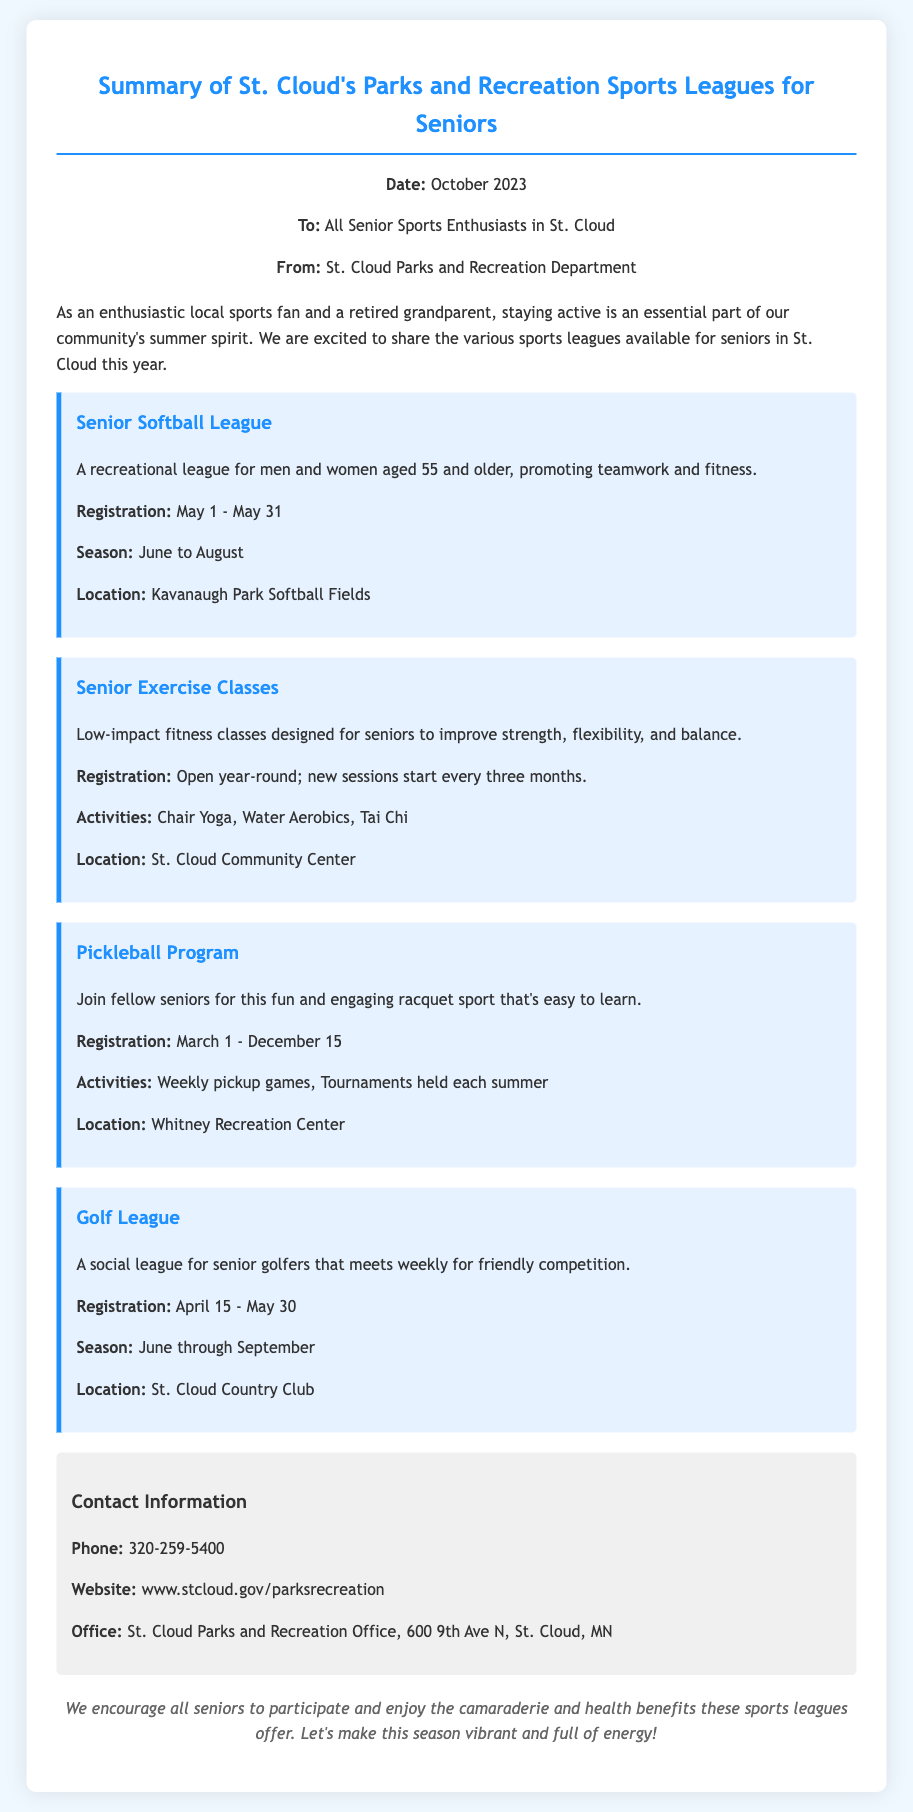What is the main theme of the memo? The main theme of the memo focuses on the various sports leagues available for seniors in St. Cloud to promote an active lifestyle.
Answer: Sports leagues for seniors When does registration for the Senior Softball League open? Registration for the Senior Softball League is specifically mentioned in the document to open on May 1.
Answer: May 1 How long is the registration period for the Golf League? The document specifies that the registration period for the Golf League extends from April 15 to May 30, which is 46 days.
Answer: 46 days What activities are included in the Senior Exercise Classes? The memo lists specific activities such as Chair Yoga, Water Aerobics, and Tai Chi included in the Senior Exercise Classes.
Answer: Chair Yoga, Water Aerobics, Tai Chi Where is the Pickleball Program located? The document states that the Pickleball Program is held at the Whitney Recreation Center.
Answer: Whitney Recreation Center What is the age requirement for the Senior Softball League? The document mentions that participants must be aged 55 and older to join the Senior Softball League.
Answer: 55 and older How often do Senior Exercise Classes start? The document indicates that new sessions for Senior Exercise Classes start every three months, implying a quarterly schedule.
Answer: Every three months What is the contact phone number for the Parks and Recreation Department? The memo provides a specific phone number for contact purposes, which is 320-259-5400.
Answer: 320-259-5400 What is the season duration for the Golf League? The document specifies that the Golf League season runs from June through September.
Answer: June through September 